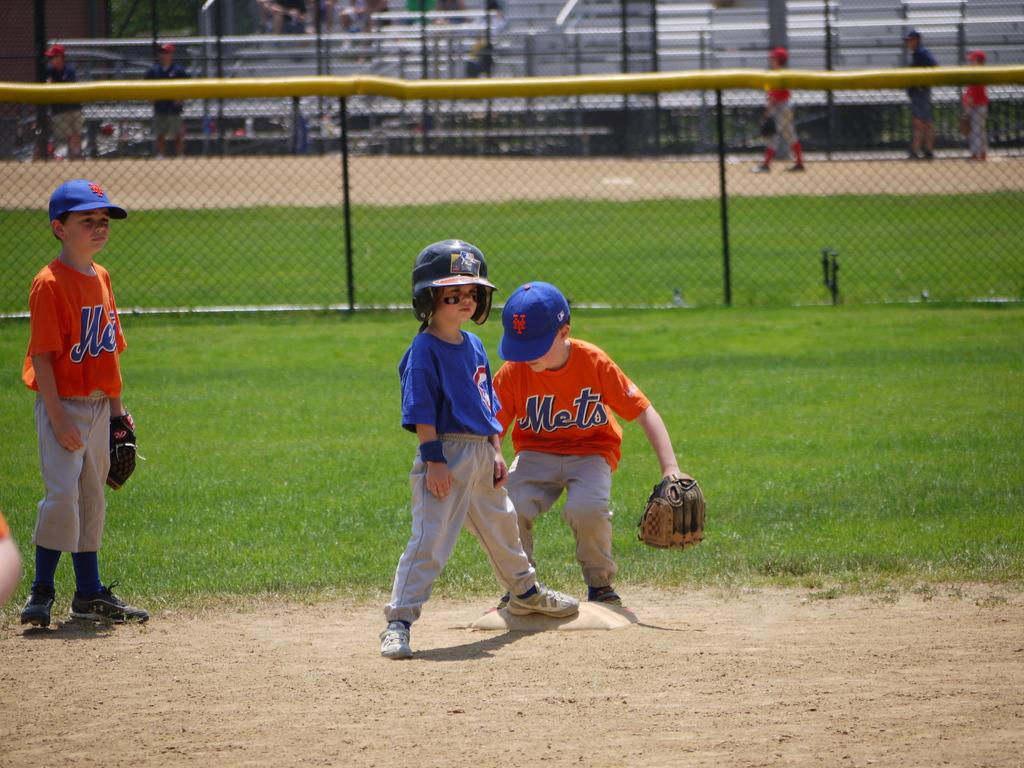<image>
Summarize the visual content of the image. A little boy in a Mets jersey stands at the base wearing his glove. 